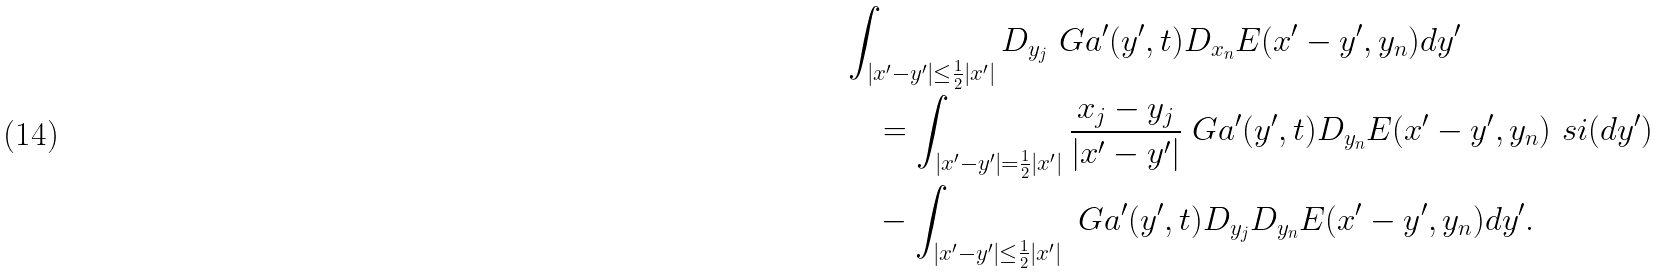<formula> <loc_0><loc_0><loc_500><loc_500>& \int _ { | x ^ { \prime } - y ^ { \prime } | \leq \frac { 1 } { 2 } | x ^ { \prime } | } D _ { y _ { j } } \ G a ^ { \prime } ( y ^ { \prime } , t ) D _ { x _ { n } } E ( x ^ { \prime } - y ^ { \prime } , y _ { n } ) d y ^ { \prime } \\ & \quad = \int _ { | x ^ { \prime } - y ^ { \prime } | = \frac { 1 } { 2 } | x ^ { \prime } | } \frac { x _ { j } - y _ { j } } { | x ^ { \prime } - y ^ { \prime } | } \ G a ^ { \prime } ( y ^ { \prime } , t ) D _ { y _ { n } } E ( x ^ { \prime } - y ^ { \prime } , y _ { n } ) \ s i ( d y ^ { \prime } ) \\ & \quad - \int _ { | x ^ { \prime } - y ^ { \prime } | \leq \frac { 1 } { 2 } | x ^ { \prime } | } \ G a ^ { \prime } ( y ^ { \prime } , t ) D _ { y _ { j } } D _ { y _ { n } } E ( x ^ { \prime } - y ^ { \prime } , y _ { n } ) d y ^ { \prime } .</formula> 